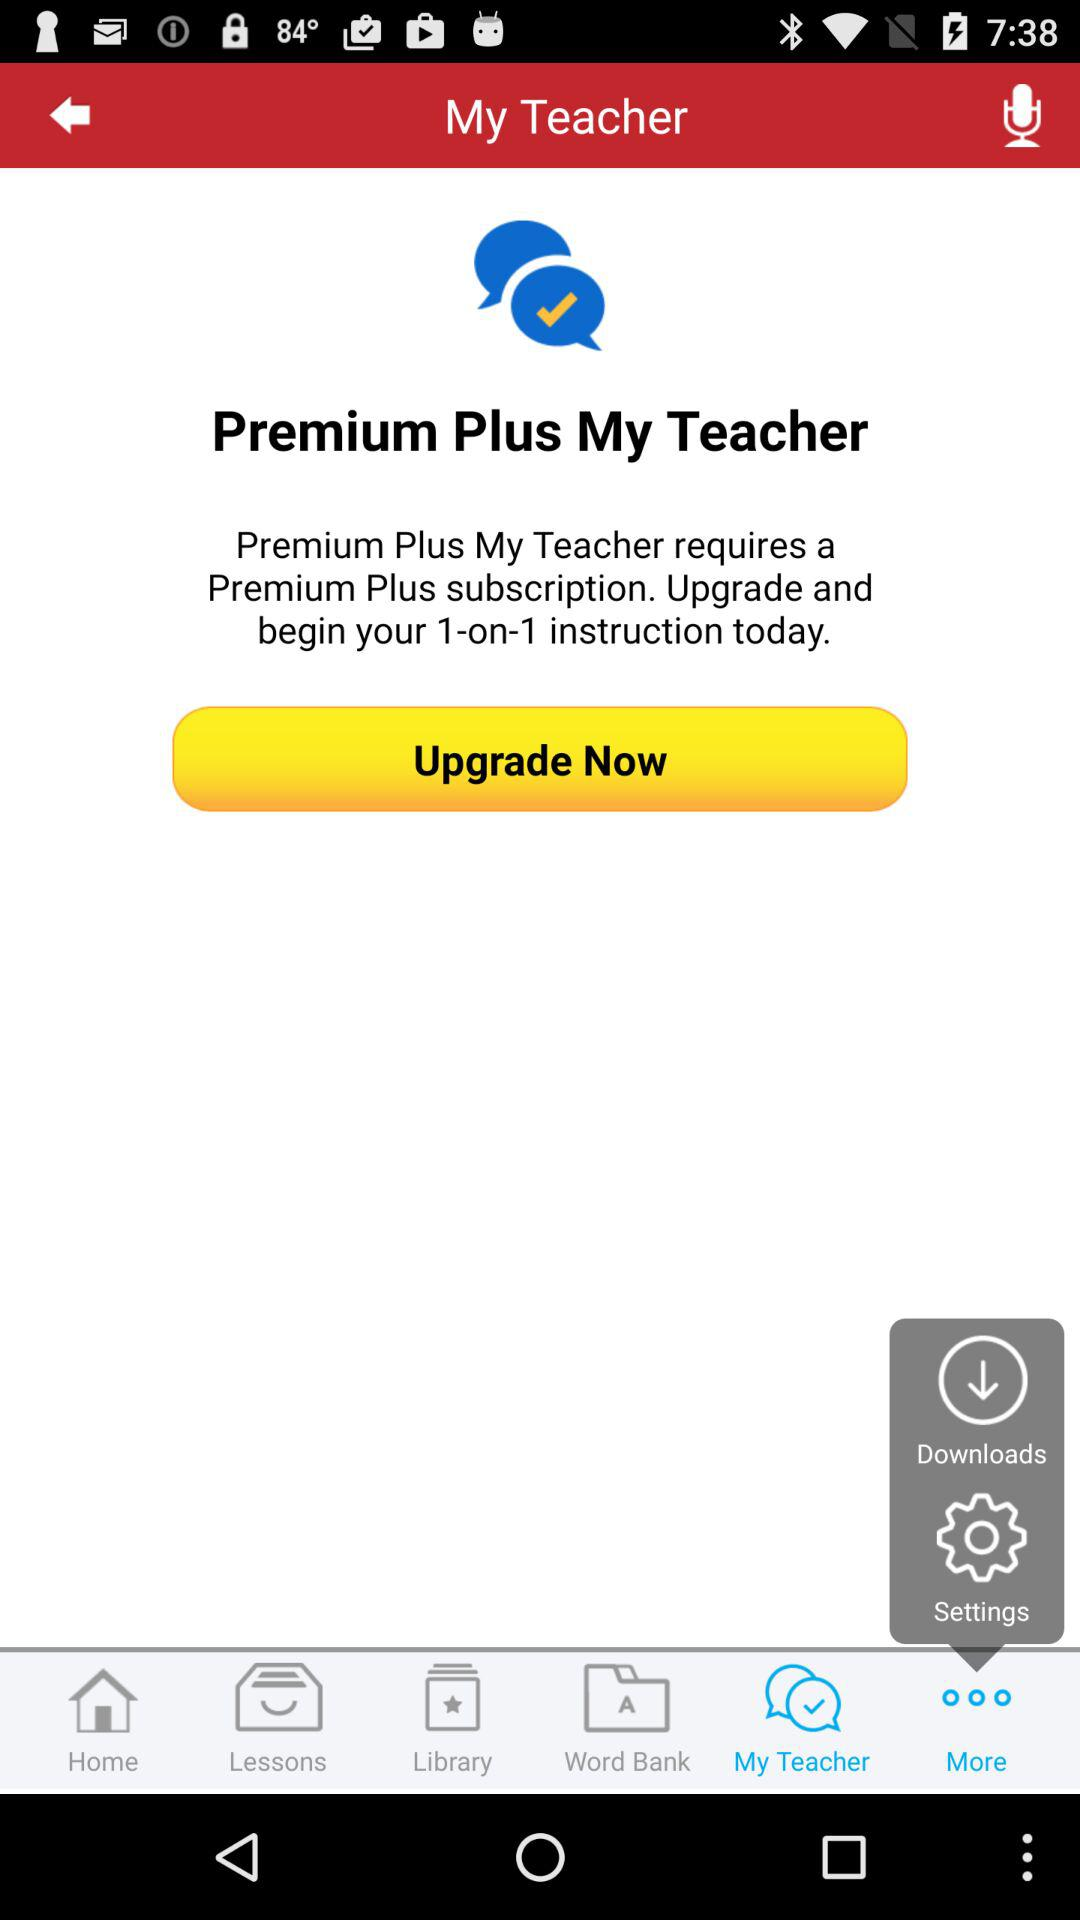What is the name of the application? The application name is "My Teacher". 